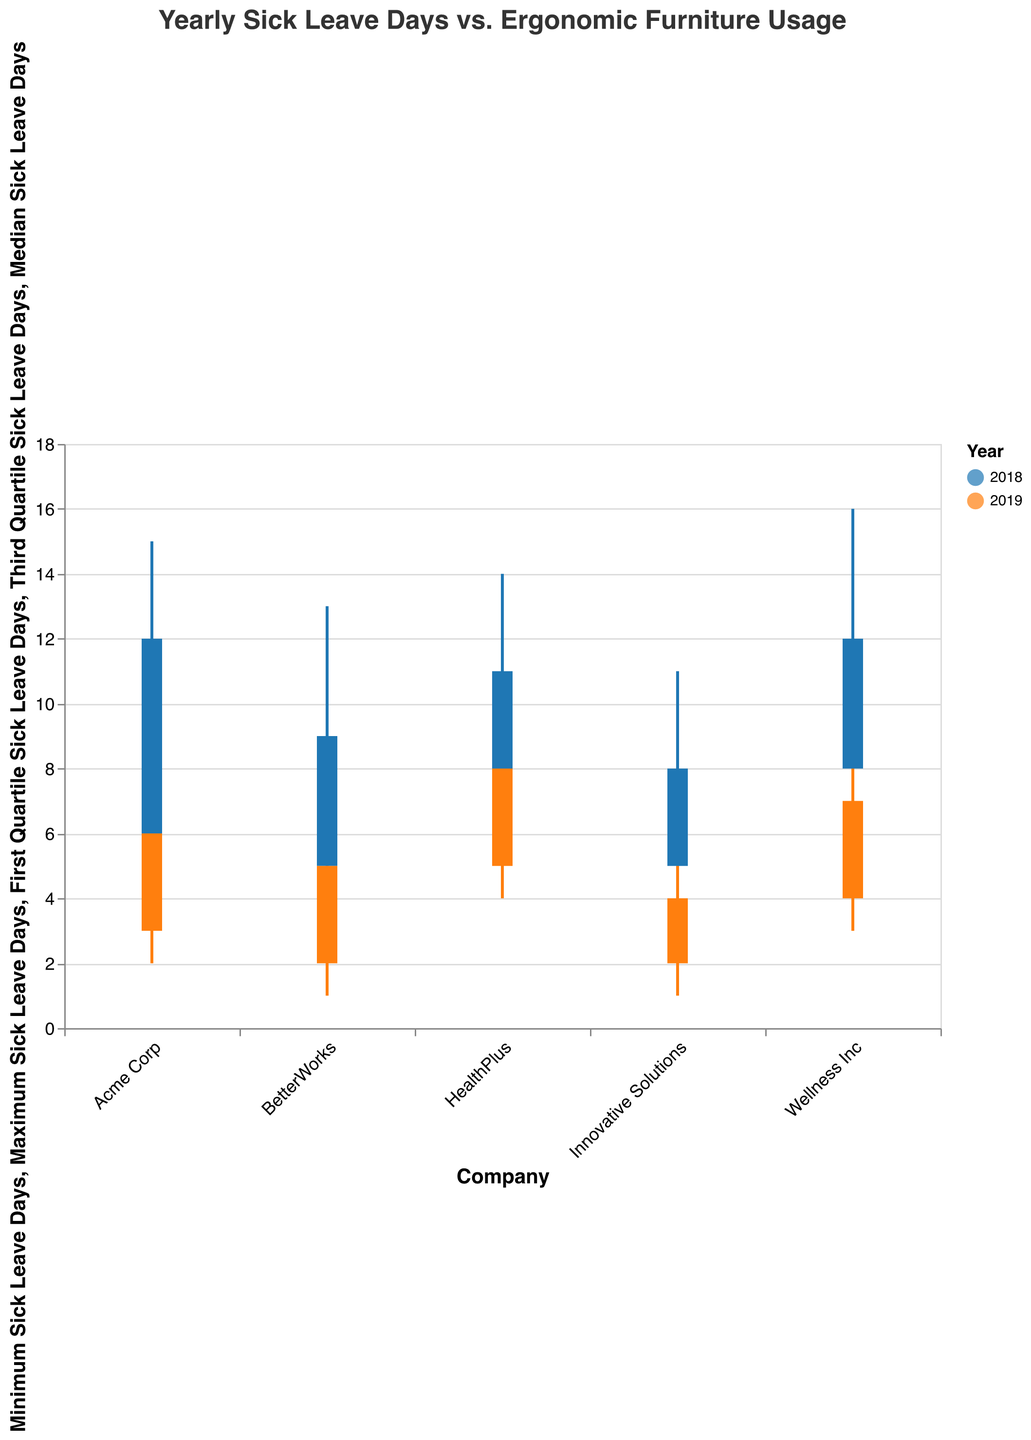What's the title of the plot? The title of the plot is displayed at the top of the chart and reads "Yearly Sick Leave Days vs. Ergonomic Furniture Usage".
Answer: Yearly Sick Leave Days vs. Ergonomic Furniture Usage Which company had the highest maximum sick leave days in 2018? By looking at the 2018 data across companies, Wellness Inc had a maximum of 16 sick leave days.
Answer: Wellness Inc What was the change in the median sick leave days for Acme Corp from 2018 to 2019? The median sick leave days for Acme Corp were 8 in 2018 and decreased to 4 in 2019. The change is 8 - 4 = 4 days.
Answer: 4 days Does any company show a reduction in both the minimum and maximum sick leave days after increasing the usage of ergonomic furniture from 2018 to 2019? BetterWorks, Innovative Solutions, and Wellness Inc all show reductions in both minimum and maximum sick leave days from 2018 to 2019, concurrent with increased ergonomic furniture usage.
Answer: BetterWorks, Innovative Solutions, and Wellness Inc What's the range of the third quartile sick leave days for HealthPlus in both years? For HealthPlus, the third quartile sick leave days were 11 in 2018 and decreased to 8 in 2019. The difference is 11 - 8 = 3.
Answer: 3 days Between Acme Corp and Wellness Inc in 2019, which company had a higher median sick leave days and what were those medians? In 2019, the median sick leave days for Acme Corp were 4, while for Wellness Inc they were 6. Wellness Inc had a higher median.
Answer: Wellness Inc, Acme Corp: 4, Wellness Inc: 6 For which company does increasing ergonomic furniture usage seem to have the least impact on median sick leave days from 2018 to 2019? By comparing the medians, HealthPlus went from 9 to 6 days, a reduction of 3 days, which appears to be a moderate reduction compared to other companies.
Answer: HealthPlus Which company had the smallest interquartile range (IQR) of sick leave days in 2018, and what was the range? The interquartile range (IQR) is the difference between the third and first quartile. For 2018, BetterWorks had the smallest IQR of 9 - 5 = 4 days.
Answer: BetterWorks, 4 days How did the first quartile sick leave days for Innovative Solutions change from 2018 to 2019? For Innovative Solutions, the first quartile sick leave days went from 5 in 2018 to 2 in 2019. The difference is 5 - 2 = 3 days.
Answer: Decreased by 3 days Which company in 2019 had the smallest maximum sick leave days and what was the value? Innovative Solutions had the smallest maximum sick leave days in 2019 with a value of 6 days.
Answer: Innovative Solutions, 6 days 